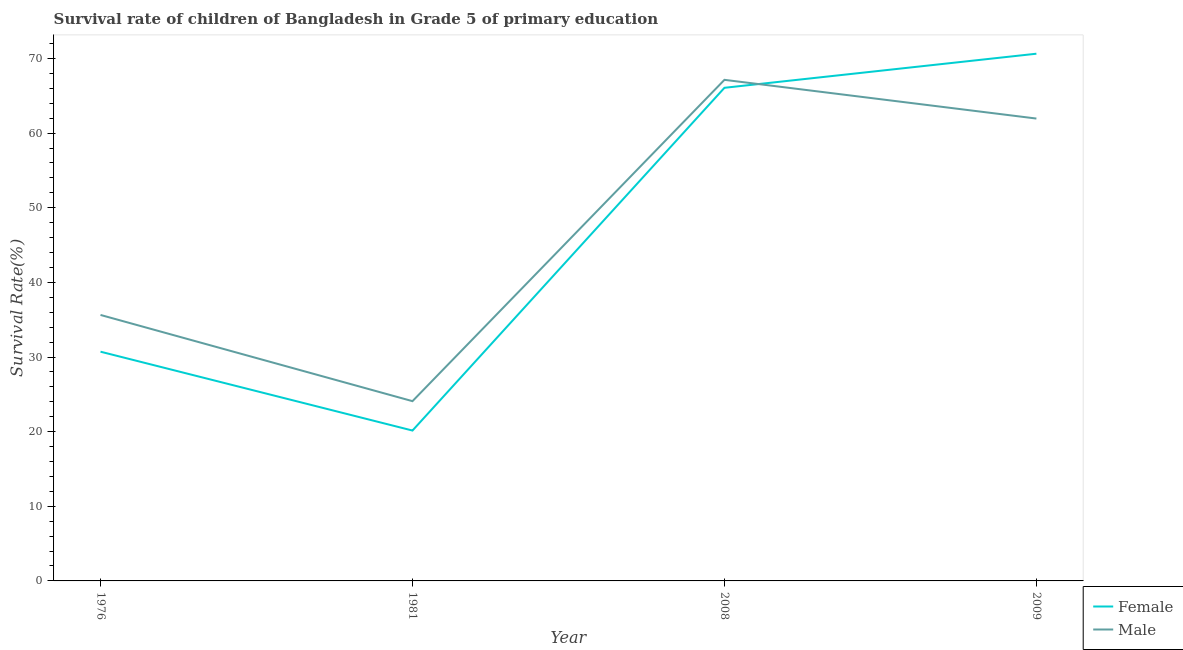Does the line corresponding to survival rate of male students in primary education intersect with the line corresponding to survival rate of female students in primary education?
Keep it short and to the point. Yes. What is the survival rate of male students in primary education in 2008?
Provide a succinct answer. 67.14. Across all years, what is the maximum survival rate of male students in primary education?
Keep it short and to the point. 67.14. Across all years, what is the minimum survival rate of male students in primary education?
Offer a very short reply. 24.09. In which year was the survival rate of male students in primary education minimum?
Provide a succinct answer. 1981. What is the total survival rate of female students in primary education in the graph?
Provide a short and direct response. 187.57. What is the difference between the survival rate of female students in primary education in 1976 and that in 2009?
Provide a short and direct response. -39.92. What is the difference between the survival rate of male students in primary education in 1981 and the survival rate of female students in primary education in 1976?
Provide a short and direct response. -6.63. What is the average survival rate of female students in primary education per year?
Keep it short and to the point. 46.89. In the year 2009, what is the difference between the survival rate of female students in primary education and survival rate of male students in primary education?
Your answer should be compact. 8.69. What is the ratio of the survival rate of female students in primary education in 1981 to that in 2008?
Give a very brief answer. 0.3. Is the survival rate of female students in primary education in 1981 less than that in 2008?
Your answer should be very brief. Yes. What is the difference between the highest and the second highest survival rate of female students in primary education?
Your answer should be compact. 4.57. What is the difference between the highest and the lowest survival rate of male students in primary education?
Give a very brief answer. 43.05. In how many years, is the survival rate of male students in primary education greater than the average survival rate of male students in primary education taken over all years?
Provide a succinct answer. 2. Is the survival rate of female students in primary education strictly greater than the survival rate of male students in primary education over the years?
Offer a terse response. No. How many years are there in the graph?
Provide a succinct answer. 4. What is the difference between two consecutive major ticks on the Y-axis?
Your answer should be compact. 10. Does the graph contain any zero values?
Offer a very short reply. No. Where does the legend appear in the graph?
Provide a succinct answer. Bottom right. How are the legend labels stacked?
Make the answer very short. Vertical. What is the title of the graph?
Give a very brief answer. Survival rate of children of Bangladesh in Grade 5 of primary education. Does "IMF nonconcessional" appear as one of the legend labels in the graph?
Provide a short and direct response. No. What is the label or title of the X-axis?
Your response must be concise. Year. What is the label or title of the Y-axis?
Keep it short and to the point. Survival Rate(%). What is the Survival Rate(%) of Female in 1976?
Offer a terse response. 30.71. What is the Survival Rate(%) of Male in 1976?
Offer a very short reply. 35.64. What is the Survival Rate(%) in Female in 1981?
Offer a terse response. 20.15. What is the Survival Rate(%) of Male in 1981?
Your answer should be very brief. 24.09. What is the Survival Rate(%) in Female in 2008?
Offer a terse response. 66.07. What is the Survival Rate(%) of Male in 2008?
Your answer should be compact. 67.14. What is the Survival Rate(%) in Female in 2009?
Offer a very short reply. 70.64. What is the Survival Rate(%) of Male in 2009?
Your answer should be very brief. 61.95. Across all years, what is the maximum Survival Rate(%) of Female?
Keep it short and to the point. 70.64. Across all years, what is the maximum Survival Rate(%) of Male?
Ensure brevity in your answer.  67.14. Across all years, what is the minimum Survival Rate(%) of Female?
Offer a very short reply. 20.15. Across all years, what is the minimum Survival Rate(%) of Male?
Your answer should be very brief. 24.09. What is the total Survival Rate(%) in Female in the graph?
Your answer should be very brief. 187.57. What is the total Survival Rate(%) in Male in the graph?
Provide a short and direct response. 188.81. What is the difference between the Survival Rate(%) of Female in 1976 and that in 1981?
Provide a short and direct response. 10.57. What is the difference between the Survival Rate(%) of Male in 1976 and that in 1981?
Offer a terse response. 11.55. What is the difference between the Survival Rate(%) of Female in 1976 and that in 2008?
Provide a succinct answer. -35.36. What is the difference between the Survival Rate(%) in Male in 1976 and that in 2008?
Ensure brevity in your answer.  -31.5. What is the difference between the Survival Rate(%) of Female in 1976 and that in 2009?
Your answer should be very brief. -39.92. What is the difference between the Survival Rate(%) of Male in 1976 and that in 2009?
Give a very brief answer. -26.31. What is the difference between the Survival Rate(%) in Female in 1981 and that in 2008?
Your answer should be compact. -45.92. What is the difference between the Survival Rate(%) in Male in 1981 and that in 2008?
Make the answer very short. -43.05. What is the difference between the Survival Rate(%) of Female in 1981 and that in 2009?
Offer a very short reply. -50.49. What is the difference between the Survival Rate(%) of Male in 1981 and that in 2009?
Offer a terse response. -37.86. What is the difference between the Survival Rate(%) in Female in 2008 and that in 2009?
Offer a very short reply. -4.57. What is the difference between the Survival Rate(%) in Male in 2008 and that in 2009?
Make the answer very short. 5.19. What is the difference between the Survival Rate(%) of Female in 1976 and the Survival Rate(%) of Male in 1981?
Make the answer very short. 6.63. What is the difference between the Survival Rate(%) of Female in 1976 and the Survival Rate(%) of Male in 2008?
Keep it short and to the point. -36.42. What is the difference between the Survival Rate(%) of Female in 1976 and the Survival Rate(%) of Male in 2009?
Offer a terse response. -31.24. What is the difference between the Survival Rate(%) of Female in 1981 and the Survival Rate(%) of Male in 2008?
Provide a short and direct response. -46.99. What is the difference between the Survival Rate(%) in Female in 1981 and the Survival Rate(%) in Male in 2009?
Your answer should be compact. -41.8. What is the difference between the Survival Rate(%) of Female in 2008 and the Survival Rate(%) of Male in 2009?
Keep it short and to the point. 4.12. What is the average Survival Rate(%) in Female per year?
Offer a very short reply. 46.89. What is the average Survival Rate(%) in Male per year?
Provide a succinct answer. 47.2. In the year 1976, what is the difference between the Survival Rate(%) in Female and Survival Rate(%) in Male?
Offer a very short reply. -4.92. In the year 1981, what is the difference between the Survival Rate(%) in Female and Survival Rate(%) in Male?
Ensure brevity in your answer.  -3.94. In the year 2008, what is the difference between the Survival Rate(%) of Female and Survival Rate(%) of Male?
Ensure brevity in your answer.  -1.07. In the year 2009, what is the difference between the Survival Rate(%) of Female and Survival Rate(%) of Male?
Provide a short and direct response. 8.69. What is the ratio of the Survival Rate(%) in Female in 1976 to that in 1981?
Your answer should be compact. 1.52. What is the ratio of the Survival Rate(%) of Male in 1976 to that in 1981?
Make the answer very short. 1.48. What is the ratio of the Survival Rate(%) in Female in 1976 to that in 2008?
Offer a terse response. 0.46. What is the ratio of the Survival Rate(%) of Male in 1976 to that in 2008?
Keep it short and to the point. 0.53. What is the ratio of the Survival Rate(%) of Female in 1976 to that in 2009?
Your answer should be very brief. 0.43. What is the ratio of the Survival Rate(%) in Male in 1976 to that in 2009?
Your answer should be very brief. 0.58. What is the ratio of the Survival Rate(%) in Female in 1981 to that in 2008?
Ensure brevity in your answer.  0.3. What is the ratio of the Survival Rate(%) in Male in 1981 to that in 2008?
Your answer should be compact. 0.36. What is the ratio of the Survival Rate(%) in Female in 1981 to that in 2009?
Give a very brief answer. 0.29. What is the ratio of the Survival Rate(%) of Male in 1981 to that in 2009?
Ensure brevity in your answer.  0.39. What is the ratio of the Survival Rate(%) in Female in 2008 to that in 2009?
Keep it short and to the point. 0.94. What is the ratio of the Survival Rate(%) in Male in 2008 to that in 2009?
Your response must be concise. 1.08. What is the difference between the highest and the second highest Survival Rate(%) of Female?
Provide a short and direct response. 4.57. What is the difference between the highest and the second highest Survival Rate(%) of Male?
Your answer should be very brief. 5.19. What is the difference between the highest and the lowest Survival Rate(%) of Female?
Your answer should be very brief. 50.49. What is the difference between the highest and the lowest Survival Rate(%) in Male?
Your answer should be compact. 43.05. 